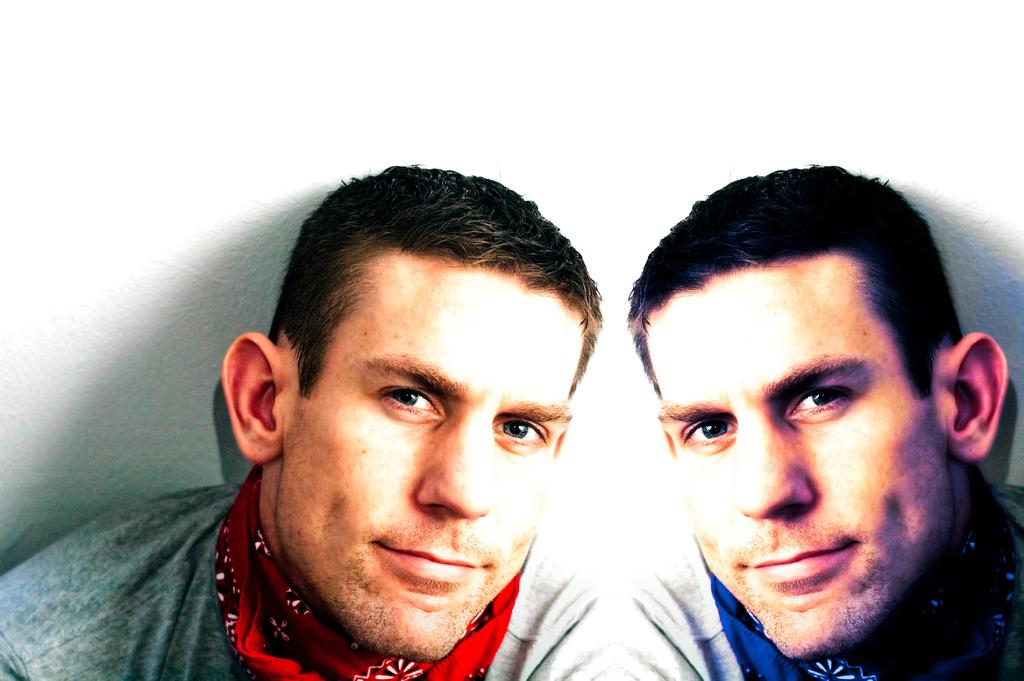What is the main subject of the image? There is a person in the image. What is the person doing in the image? The person is watching and smiling. Can you describe the person's position in the image? The same person appears on the right side of the image. What is the background of the image? The background of the image is a white wall. What type of vase is present on the canvas in the image? There is no vase or canvas present in the image. The background is a plain white wall. 